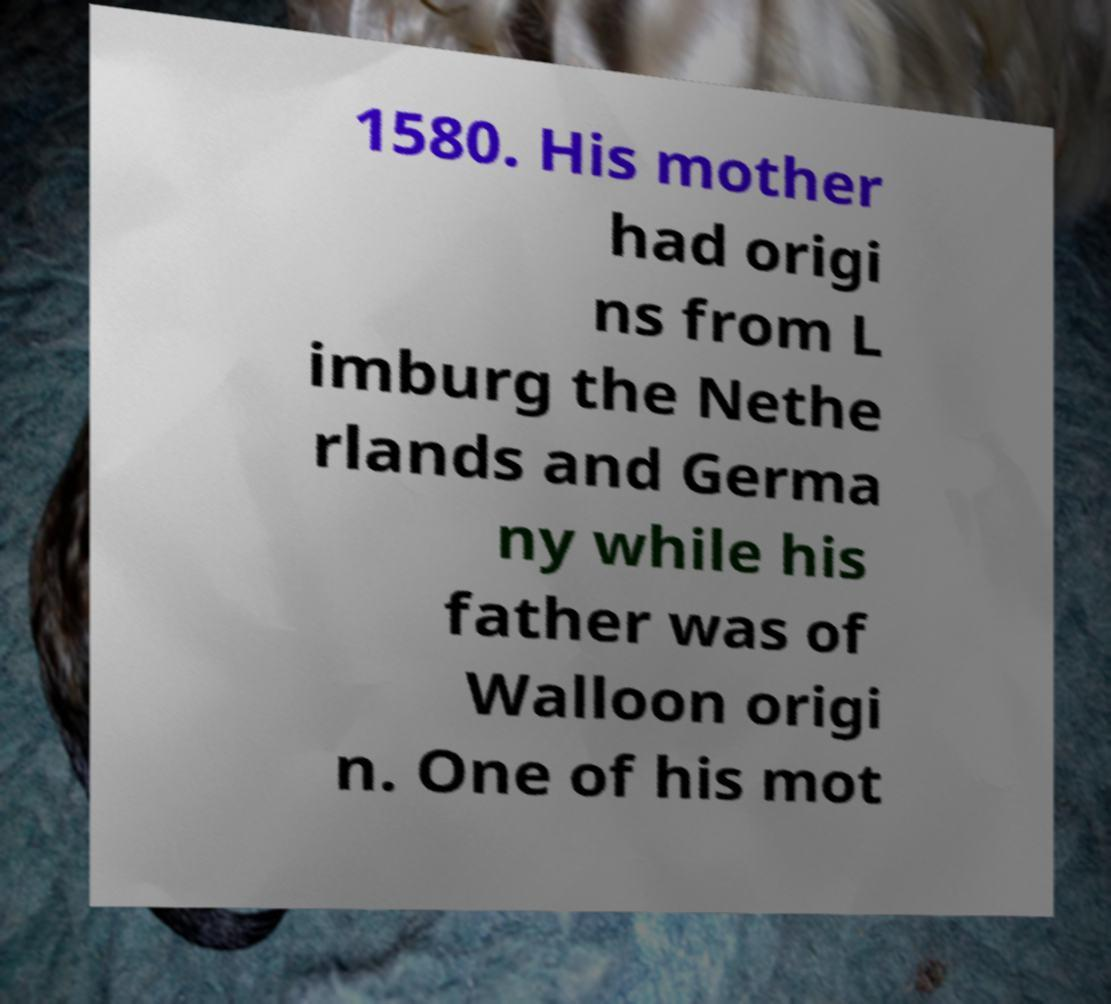Could you extract and type out the text from this image? 1580. His mother had origi ns from L imburg the Nethe rlands and Germa ny while his father was of Walloon origi n. One of his mot 